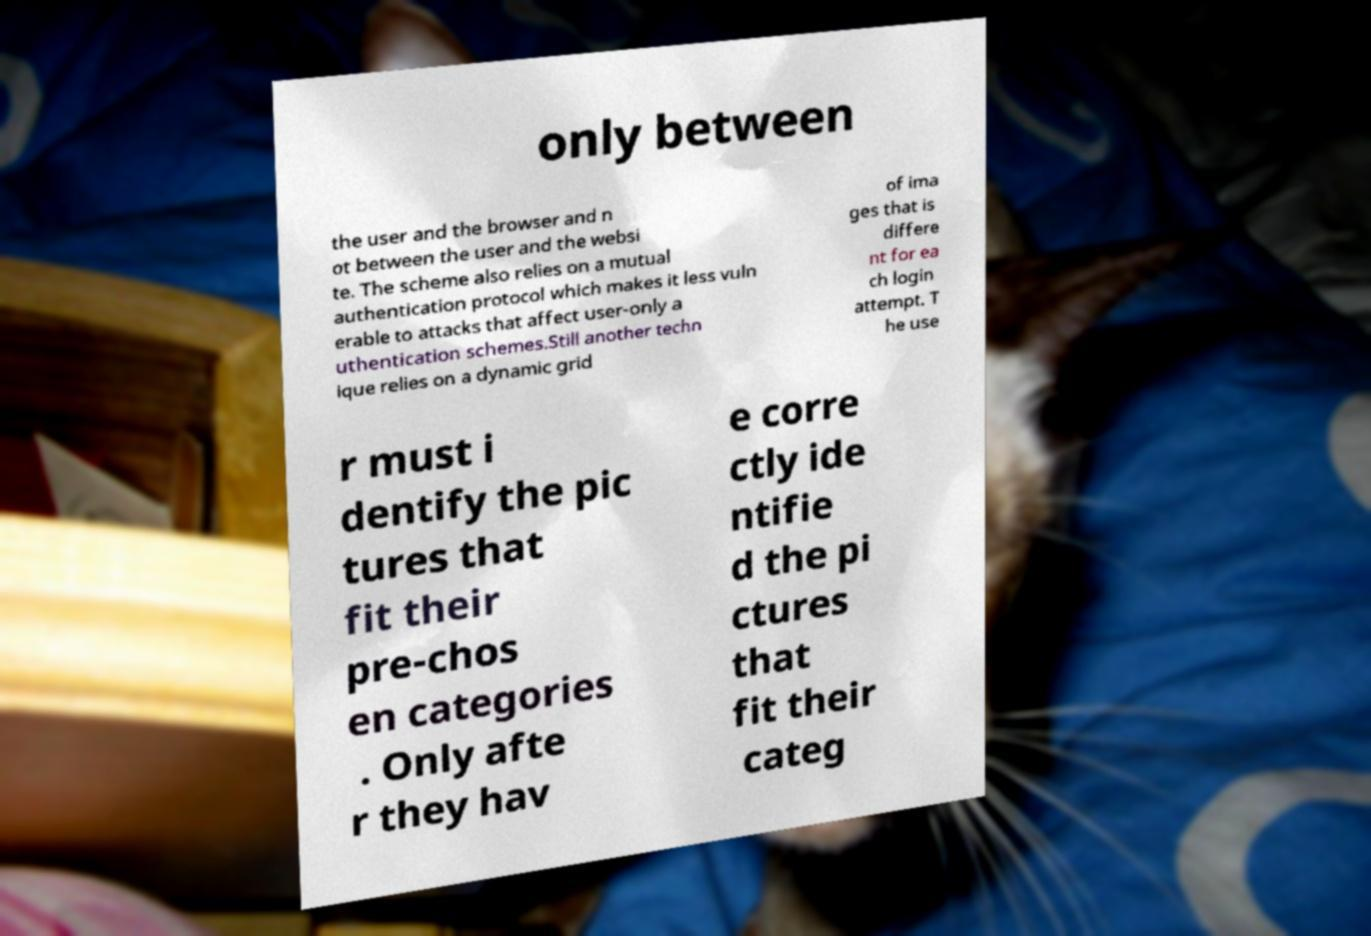I need the written content from this picture converted into text. Can you do that? only between the user and the browser and n ot between the user and the websi te. The scheme also relies on a mutual authentication protocol which makes it less vuln erable to attacks that affect user-only a uthentication schemes.Still another techn ique relies on a dynamic grid of ima ges that is differe nt for ea ch login attempt. T he use r must i dentify the pic tures that fit their pre-chos en categories . Only afte r they hav e corre ctly ide ntifie d the pi ctures that fit their categ 